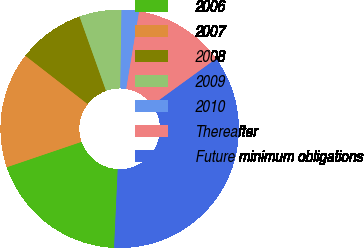Convert chart to OTSL. <chart><loc_0><loc_0><loc_500><loc_500><pie_chart><fcel>2006<fcel>2007<fcel>2008<fcel>2009<fcel>2010<fcel>Thereafter<fcel>Future minimum obligations<nl><fcel>19.05%<fcel>15.72%<fcel>9.04%<fcel>5.71%<fcel>2.37%<fcel>12.38%<fcel>35.73%<nl></chart> 